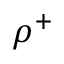<formula> <loc_0><loc_0><loc_500><loc_500>\rho ^ { + }</formula> 